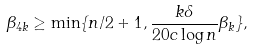Convert formula to latex. <formula><loc_0><loc_0><loc_500><loc_500>\beta _ { 4 k } \geq \min \{ n / 2 + 1 , \frac { k \delta } { 2 0 c \log n } \beta _ { k } \} ,</formula> 